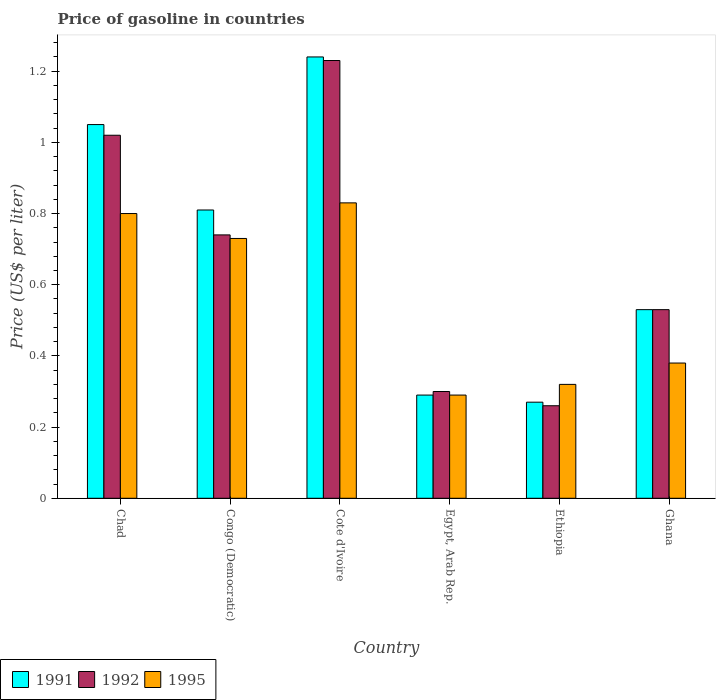Are the number of bars on each tick of the X-axis equal?
Keep it short and to the point. Yes. How many bars are there on the 5th tick from the left?
Ensure brevity in your answer.  3. How many bars are there on the 6th tick from the right?
Your answer should be compact. 3. In how many cases, is the number of bars for a given country not equal to the number of legend labels?
Provide a succinct answer. 0. Across all countries, what is the maximum price of gasoline in 1991?
Make the answer very short. 1.24. Across all countries, what is the minimum price of gasoline in 1991?
Make the answer very short. 0.27. In which country was the price of gasoline in 1992 maximum?
Your answer should be compact. Cote d'Ivoire. In which country was the price of gasoline in 1995 minimum?
Offer a very short reply. Egypt, Arab Rep. What is the total price of gasoline in 1992 in the graph?
Provide a succinct answer. 4.08. What is the difference between the price of gasoline in 1992 in Chad and that in Cote d'Ivoire?
Give a very brief answer. -0.21. What is the difference between the price of gasoline in 1991 in Congo (Democratic) and the price of gasoline in 1992 in Ethiopia?
Provide a short and direct response. 0.55. What is the average price of gasoline in 1991 per country?
Give a very brief answer. 0.7. What is the difference between the price of gasoline of/in 1992 and price of gasoline of/in 1991 in Ethiopia?
Keep it short and to the point. -0.01. What is the ratio of the price of gasoline in 1995 in Chad to that in Congo (Democratic)?
Your response must be concise. 1.1. What is the difference between the highest and the second highest price of gasoline in 1992?
Ensure brevity in your answer.  -0.49. What is the difference between the highest and the lowest price of gasoline in 1995?
Offer a terse response. 0.54. What does the 1st bar from the right in Congo (Democratic) represents?
Ensure brevity in your answer.  1995. Is it the case that in every country, the sum of the price of gasoline in 1991 and price of gasoline in 1995 is greater than the price of gasoline in 1992?
Your answer should be very brief. Yes. How many bars are there?
Make the answer very short. 18. How many countries are there in the graph?
Your answer should be compact. 6. What is the difference between two consecutive major ticks on the Y-axis?
Give a very brief answer. 0.2. Does the graph contain any zero values?
Your answer should be very brief. No. Does the graph contain grids?
Keep it short and to the point. No. Where does the legend appear in the graph?
Provide a succinct answer. Bottom left. What is the title of the graph?
Your answer should be very brief. Price of gasoline in countries. Does "1965" appear as one of the legend labels in the graph?
Your answer should be very brief. No. What is the label or title of the X-axis?
Give a very brief answer. Country. What is the label or title of the Y-axis?
Your answer should be compact. Price (US$ per liter). What is the Price (US$ per liter) of 1995 in Chad?
Offer a very short reply. 0.8. What is the Price (US$ per liter) of 1991 in Congo (Democratic)?
Offer a terse response. 0.81. What is the Price (US$ per liter) of 1992 in Congo (Democratic)?
Your answer should be compact. 0.74. What is the Price (US$ per liter) of 1995 in Congo (Democratic)?
Ensure brevity in your answer.  0.73. What is the Price (US$ per liter) in 1991 in Cote d'Ivoire?
Your answer should be very brief. 1.24. What is the Price (US$ per liter) in 1992 in Cote d'Ivoire?
Your answer should be compact. 1.23. What is the Price (US$ per liter) in 1995 in Cote d'Ivoire?
Offer a very short reply. 0.83. What is the Price (US$ per liter) of 1991 in Egypt, Arab Rep.?
Your answer should be very brief. 0.29. What is the Price (US$ per liter) in 1995 in Egypt, Arab Rep.?
Keep it short and to the point. 0.29. What is the Price (US$ per liter) of 1991 in Ethiopia?
Make the answer very short. 0.27. What is the Price (US$ per liter) of 1992 in Ethiopia?
Your response must be concise. 0.26. What is the Price (US$ per liter) in 1995 in Ethiopia?
Offer a very short reply. 0.32. What is the Price (US$ per liter) in 1991 in Ghana?
Keep it short and to the point. 0.53. What is the Price (US$ per liter) in 1992 in Ghana?
Make the answer very short. 0.53. What is the Price (US$ per liter) of 1995 in Ghana?
Your answer should be very brief. 0.38. Across all countries, what is the maximum Price (US$ per liter) of 1991?
Your response must be concise. 1.24. Across all countries, what is the maximum Price (US$ per liter) in 1992?
Your response must be concise. 1.23. Across all countries, what is the maximum Price (US$ per liter) of 1995?
Offer a very short reply. 0.83. Across all countries, what is the minimum Price (US$ per liter) in 1991?
Your response must be concise. 0.27. Across all countries, what is the minimum Price (US$ per liter) of 1992?
Ensure brevity in your answer.  0.26. Across all countries, what is the minimum Price (US$ per liter) of 1995?
Your answer should be compact. 0.29. What is the total Price (US$ per liter) of 1991 in the graph?
Provide a short and direct response. 4.19. What is the total Price (US$ per liter) of 1992 in the graph?
Your response must be concise. 4.08. What is the total Price (US$ per liter) in 1995 in the graph?
Your answer should be very brief. 3.35. What is the difference between the Price (US$ per liter) in 1991 in Chad and that in Congo (Democratic)?
Provide a succinct answer. 0.24. What is the difference between the Price (US$ per liter) in 1992 in Chad and that in Congo (Democratic)?
Your response must be concise. 0.28. What is the difference between the Price (US$ per liter) of 1995 in Chad and that in Congo (Democratic)?
Provide a succinct answer. 0.07. What is the difference between the Price (US$ per liter) in 1991 in Chad and that in Cote d'Ivoire?
Your response must be concise. -0.19. What is the difference between the Price (US$ per liter) of 1992 in Chad and that in Cote d'Ivoire?
Your answer should be compact. -0.21. What is the difference between the Price (US$ per liter) of 1995 in Chad and that in Cote d'Ivoire?
Offer a very short reply. -0.03. What is the difference between the Price (US$ per liter) in 1991 in Chad and that in Egypt, Arab Rep.?
Provide a succinct answer. 0.76. What is the difference between the Price (US$ per liter) of 1992 in Chad and that in Egypt, Arab Rep.?
Provide a succinct answer. 0.72. What is the difference between the Price (US$ per liter) in 1995 in Chad and that in Egypt, Arab Rep.?
Make the answer very short. 0.51. What is the difference between the Price (US$ per liter) in 1991 in Chad and that in Ethiopia?
Make the answer very short. 0.78. What is the difference between the Price (US$ per liter) of 1992 in Chad and that in Ethiopia?
Offer a very short reply. 0.76. What is the difference between the Price (US$ per liter) of 1995 in Chad and that in Ethiopia?
Offer a terse response. 0.48. What is the difference between the Price (US$ per liter) of 1991 in Chad and that in Ghana?
Provide a short and direct response. 0.52. What is the difference between the Price (US$ per liter) of 1992 in Chad and that in Ghana?
Offer a very short reply. 0.49. What is the difference between the Price (US$ per liter) in 1995 in Chad and that in Ghana?
Your answer should be compact. 0.42. What is the difference between the Price (US$ per liter) of 1991 in Congo (Democratic) and that in Cote d'Ivoire?
Give a very brief answer. -0.43. What is the difference between the Price (US$ per liter) in 1992 in Congo (Democratic) and that in Cote d'Ivoire?
Your response must be concise. -0.49. What is the difference between the Price (US$ per liter) in 1995 in Congo (Democratic) and that in Cote d'Ivoire?
Give a very brief answer. -0.1. What is the difference between the Price (US$ per liter) in 1991 in Congo (Democratic) and that in Egypt, Arab Rep.?
Make the answer very short. 0.52. What is the difference between the Price (US$ per liter) in 1992 in Congo (Democratic) and that in Egypt, Arab Rep.?
Your response must be concise. 0.44. What is the difference between the Price (US$ per liter) of 1995 in Congo (Democratic) and that in Egypt, Arab Rep.?
Make the answer very short. 0.44. What is the difference between the Price (US$ per liter) in 1991 in Congo (Democratic) and that in Ethiopia?
Ensure brevity in your answer.  0.54. What is the difference between the Price (US$ per liter) of 1992 in Congo (Democratic) and that in Ethiopia?
Ensure brevity in your answer.  0.48. What is the difference between the Price (US$ per liter) of 1995 in Congo (Democratic) and that in Ethiopia?
Your answer should be compact. 0.41. What is the difference between the Price (US$ per liter) of 1991 in Congo (Democratic) and that in Ghana?
Make the answer very short. 0.28. What is the difference between the Price (US$ per liter) of 1992 in Congo (Democratic) and that in Ghana?
Provide a short and direct response. 0.21. What is the difference between the Price (US$ per liter) of 1991 in Cote d'Ivoire and that in Egypt, Arab Rep.?
Your answer should be very brief. 0.95. What is the difference between the Price (US$ per liter) in 1992 in Cote d'Ivoire and that in Egypt, Arab Rep.?
Keep it short and to the point. 0.93. What is the difference between the Price (US$ per liter) in 1995 in Cote d'Ivoire and that in Egypt, Arab Rep.?
Keep it short and to the point. 0.54. What is the difference between the Price (US$ per liter) in 1992 in Cote d'Ivoire and that in Ethiopia?
Make the answer very short. 0.97. What is the difference between the Price (US$ per liter) of 1995 in Cote d'Ivoire and that in Ethiopia?
Ensure brevity in your answer.  0.51. What is the difference between the Price (US$ per liter) in 1991 in Cote d'Ivoire and that in Ghana?
Keep it short and to the point. 0.71. What is the difference between the Price (US$ per liter) of 1995 in Cote d'Ivoire and that in Ghana?
Ensure brevity in your answer.  0.45. What is the difference between the Price (US$ per liter) of 1991 in Egypt, Arab Rep. and that in Ethiopia?
Offer a terse response. 0.02. What is the difference between the Price (US$ per liter) in 1992 in Egypt, Arab Rep. and that in Ethiopia?
Offer a very short reply. 0.04. What is the difference between the Price (US$ per liter) in 1995 in Egypt, Arab Rep. and that in Ethiopia?
Ensure brevity in your answer.  -0.03. What is the difference between the Price (US$ per liter) of 1991 in Egypt, Arab Rep. and that in Ghana?
Keep it short and to the point. -0.24. What is the difference between the Price (US$ per liter) in 1992 in Egypt, Arab Rep. and that in Ghana?
Keep it short and to the point. -0.23. What is the difference between the Price (US$ per liter) in 1995 in Egypt, Arab Rep. and that in Ghana?
Your response must be concise. -0.09. What is the difference between the Price (US$ per liter) in 1991 in Ethiopia and that in Ghana?
Your answer should be very brief. -0.26. What is the difference between the Price (US$ per liter) of 1992 in Ethiopia and that in Ghana?
Keep it short and to the point. -0.27. What is the difference between the Price (US$ per liter) in 1995 in Ethiopia and that in Ghana?
Keep it short and to the point. -0.06. What is the difference between the Price (US$ per liter) of 1991 in Chad and the Price (US$ per liter) of 1992 in Congo (Democratic)?
Provide a succinct answer. 0.31. What is the difference between the Price (US$ per liter) of 1991 in Chad and the Price (US$ per liter) of 1995 in Congo (Democratic)?
Your response must be concise. 0.32. What is the difference between the Price (US$ per liter) in 1992 in Chad and the Price (US$ per liter) in 1995 in Congo (Democratic)?
Your response must be concise. 0.29. What is the difference between the Price (US$ per liter) in 1991 in Chad and the Price (US$ per liter) in 1992 in Cote d'Ivoire?
Provide a short and direct response. -0.18. What is the difference between the Price (US$ per liter) of 1991 in Chad and the Price (US$ per liter) of 1995 in Cote d'Ivoire?
Provide a short and direct response. 0.22. What is the difference between the Price (US$ per liter) of 1992 in Chad and the Price (US$ per liter) of 1995 in Cote d'Ivoire?
Your answer should be compact. 0.19. What is the difference between the Price (US$ per liter) in 1991 in Chad and the Price (US$ per liter) in 1992 in Egypt, Arab Rep.?
Keep it short and to the point. 0.75. What is the difference between the Price (US$ per liter) in 1991 in Chad and the Price (US$ per liter) in 1995 in Egypt, Arab Rep.?
Offer a very short reply. 0.76. What is the difference between the Price (US$ per liter) of 1992 in Chad and the Price (US$ per liter) of 1995 in Egypt, Arab Rep.?
Your response must be concise. 0.73. What is the difference between the Price (US$ per liter) of 1991 in Chad and the Price (US$ per liter) of 1992 in Ethiopia?
Provide a succinct answer. 0.79. What is the difference between the Price (US$ per liter) of 1991 in Chad and the Price (US$ per liter) of 1995 in Ethiopia?
Offer a very short reply. 0.73. What is the difference between the Price (US$ per liter) in 1992 in Chad and the Price (US$ per liter) in 1995 in Ethiopia?
Give a very brief answer. 0.7. What is the difference between the Price (US$ per liter) in 1991 in Chad and the Price (US$ per liter) in 1992 in Ghana?
Give a very brief answer. 0.52. What is the difference between the Price (US$ per liter) in 1991 in Chad and the Price (US$ per liter) in 1995 in Ghana?
Your answer should be very brief. 0.67. What is the difference between the Price (US$ per liter) in 1992 in Chad and the Price (US$ per liter) in 1995 in Ghana?
Your answer should be very brief. 0.64. What is the difference between the Price (US$ per liter) of 1991 in Congo (Democratic) and the Price (US$ per liter) of 1992 in Cote d'Ivoire?
Your answer should be compact. -0.42. What is the difference between the Price (US$ per liter) of 1991 in Congo (Democratic) and the Price (US$ per liter) of 1995 in Cote d'Ivoire?
Provide a succinct answer. -0.02. What is the difference between the Price (US$ per liter) of 1992 in Congo (Democratic) and the Price (US$ per liter) of 1995 in Cote d'Ivoire?
Provide a succinct answer. -0.09. What is the difference between the Price (US$ per liter) in 1991 in Congo (Democratic) and the Price (US$ per liter) in 1992 in Egypt, Arab Rep.?
Provide a succinct answer. 0.51. What is the difference between the Price (US$ per liter) of 1991 in Congo (Democratic) and the Price (US$ per liter) of 1995 in Egypt, Arab Rep.?
Keep it short and to the point. 0.52. What is the difference between the Price (US$ per liter) of 1992 in Congo (Democratic) and the Price (US$ per liter) of 1995 in Egypt, Arab Rep.?
Provide a succinct answer. 0.45. What is the difference between the Price (US$ per liter) in 1991 in Congo (Democratic) and the Price (US$ per liter) in 1992 in Ethiopia?
Your answer should be compact. 0.55. What is the difference between the Price (US$ per liter) in 1991 in Congo (Democratic) and the Price (US$ per liter) in 1995 in Ethiopia?
Your answer should be very brief. 0.49. What is the difference between the Price (US$ per liter) in 1992 in Congo (Democratic) and the Price (US$ per liter) in 1995 in Ethiopia?
Your answer should be very brief. 0.42. What is the difference between the Price (US$ per liter) in 1991 in Congo (Democratic) and the Price (US$ per liter) in 1992 in Ghana?
Keep it short and to the point. 0.28. What is the difference between the Price (US$ per liter) in 1991 in Congo (Democratic) and the Price (US$ per liter) in 1995 in Ghana?
Keep it short and to the point. 0.43. What is the difference between the Price (US$ per liter) of 1992 in Congo (Democratic) and the Price (US$ per liter) of 1995 in Ghana?
Provide a short and direct response. 0.36. What is the difference between the Price (US$ per liter) in 1991 in Cote d'Ivoire and the Price (US$ per liter) in 1992 in Egypt, Arab Rep.?
Offer a very short reply. 0.94. What is the difference between the Price (US$ per liter) of 1991 in Cote d'Ivoire and the Price (US$ per liter) of 1995 in Egypt, Arab Rep.?
Keep it short and to the point. 0.95. What is the difference between the Price (US$ per liter) in 1991 in Cote d'Ivoire and the Price (US$ per liter) in 1992 in Ethiopia?
Give a very brief answer. 0.98. What is the difference between the Price (US$ per liter) of 1992 in Cote d'Ivoire and the Price (US$ per liter) of 1995 in Ethiopia?
Provide a short and direct response. 0.91. What is the difference between the Price (US$ per liter) in 1991 in Cote d'Ivoire and the Price (US$ per liter) in 1992 in Ghana?
Offer a very short reply. 0.71. What is the difference between the Price (US$ per liter) in 1991 in Cote d'Ivoire and the Price (US$ per liter) in 1995 in Ghana?
Your answer should be compact. 0.86. What is the difference between the Price (US$ per liter) of 1992 in Cote d'Ivoire and the Price (US$ per liter) of 1995 in Ghana?
Provide a succinct answer. 0.85. What is the difference between the Price (US$ per liter) in 1991 in Egypt, Arab Rep. and the Price (US$ per liter) in 1992 in Ethiopia?
Ensure brevity in your answer.  0.03. What is the difference between the Price (US$ per liter) of 1991 in Egypt, Arab Rep. and the Price (US$ per liter) of 1995 in Ethiopia?
Your answer should be very brief. -0.03. What is the difference between the Price (US$ per liter) in 1992 in Egypt, Arab Rep. and the Price (US$ per liter) in 1995 in Ethiopia?
Offer a terse response. -0.02. What is the difference between the Price (US$ per liter) of 1991 in Egypt, Arab Rep. and the Price (US$ per liter) of 1992 in Ghana?
Make the answer very short. -0.24. What is the difference between the Price (US$ per liter) of 1991 in Egypt, Arab Rep. and the Price (US$ per liter) of 1995 in Ghana?
Your response must be concise. -0.09. What is the difference between the Price (US$ per liter) in 1992 in Egypt, Arab Rep. and the Price (US$ per liter) in 1995 in Ghana?
Make the answer very short. -0.08. What is the difference between the Price (US$ per liter) in 1991 in Ethiopia and the Price (US$ per liter) in 1992 in Ghana?
Provide a succinct answer. -0.26. What is the difference between the Price (US$ per liter) in 1991 in Ethiopia and the Price (US$ per liter) in 1995 in Ghana?
Give a very brief answer. -0.11. What is the difference between the Price (US$ per liter) in 1992 in Ethiopia and the Price (US$ per liter) in 1995 in Ghana?
Ensure brevity in your answer.  -0.12. What is the average Price (US$ per liter) of 1991 per country?
Provide a short and direct response. 0.7. What is the average Price (US$ per liter) of 1992 per country?
Provide a succinct answer. 0.68. What is the average Price (US$ per liter) of 1995 per country?
Your answer should be compact. 0.56. What is the difference between the Price (US$ per liter) in 1991 and Price (US$ per liter) in 1995 in Chad?
Your answer should be very brief. 0.25. What is the difference between the Price (US$ per liter) in 1992 and Price (US$ per liter) in 1995 in Chad?
Your answer should be compact. 0.22. What is the difference between the Price (US$ per liter) in 1991 and Price (US$ per liter) in 1992 in Congo (Democratic)?
Offer a very short reply. 0.07. What is the difference between the Price (US$ per liter) in 1991 and Price (US$ per liter) in 1995 in Congo (Democratic)?
Provide a short and direct response. 0.08. What is the difference between the Price (US$ per liter) in 1991 and Price (US$ per liter) in 1995 in Cote d'Ivoire?
Provide a succinct answer. 0.41. What is the difference between the Price (US$ per liter) in 1991 and Price (US$ per liter) in 1992 in Egypt, Arab Rep.?
Your answer should be very brief. -0.01. What is the difference between the Price (US$ per liter) of 1992 and Price (US$ per liter) of 1995 in Egypt, Arab Rep.?
Your answer should be compact. 0.01. What is the difference between the Price (US$ per liter) in 1991 and Price (US$ per liter) in 1992 in Ethiopia?
Your answer should be very brief. 0.01. What is the difference between the Price (US$ per liter) in 1992 and Price (US$ per liter) in 1995 in Ethiopia?
Provide a succinct answer. -0.06. What is the difference between the Price (US$ per liter) of 1991 and Price (US$ per liter) of 1995 in Ghana?
Your answer should be very brief. 0.15. What is the ratio of the Price (US$ per liter) of 1991 in Chad to that in Congo (Democratic)?
Ensure brevity in your answer.  1.3. What is the ratio of the Price (US$ per liter) of 1992 in Chad to that in Congo (Democratic)?
Make the answer very short. 1.38. What is the ratio of the Price (US$ per liter) of 1995 in Chad to that in Congo (Democratic)?
Your answer should be compact. 1.1. What is the ratio of the Price (US$ per liter) in 1991 in Chad to that in Cote d'Ivoire?
Your response must be concise. 0.85. What is the ratio of the Price (US$ per liter) in 1992 in Chad to that in Cote d'Ivoire?
Give a very brief answer. 0.83. What is the ratio of the Price (US$ per liter) in 1995 in Chad to that in Cote d'Ivoire?
Provide a succinct answer. 0.96. What is the ratio of the Price (US$ per liter) in 1991 in Chad to that in Egypt, Arab Rep.?
Provide a short and direct response. 3.62. What is the ratio of the Price (US$ per liter) in 1992 in Chad to that in Egypt, Arab Rep.?
Offer a very short reply. 3.4. What is the ratio of the Price (US$ per liter) of 1995 in Chad to that in Egypt, Arab Rep.?
Provide a succinct answer. 2.76. What is the ratio of the Price (US$ per liter) of 1991 in Chad to that in Ethiopia?
Ensure brevity in your answer.  3.89. What is the ratio of the Price (US$ per liter) in 1992 in Chad to that in Ethiopia?
Ensure brevity in your answer.  3.92. What is the ratio of the Price (US$ per liter) in 1991 in Chad to that in Ghana?
Your answer should be compact. 1.98. What is the ratio of the Price (US$ per liter) of 1992 in Chad to that in Ghana?
Offer a very short reply. 1.92. What is the ratio of the Price (US$ per liter) of 1995 in Chad to that in Ghana?
Offer a very short reply. 2.11. What is the ratio of the Price (US$ per liter) in 1991 in Congo (Democratic) to that in Cote d'Ivoire?
Keep it short and to the point. 0.65. What is the ratio of the Price (US$ per liter) of 1992 in Congo (Democratic) to that in Cote d'Ivoire?
Provide a succinct answer. 0.6. What is the ratio of the Price (US$ per liter) in 1995 in Congo (Democratic) to that in Cote d'Ivoire?
Give a very brief answer. 0.88. What is the ratio of the Price (US$ per liter) in 1991 in Congo (Democratic) to that in Egypt, Arab Rep.?
Offer a terse response. 2.79. What is the ratio of the Price (US$ per liter) of 1992 in Congo (Democratic) to that in Egypt, Arab Rep.?
Make the answer very short. 2.47. What is the ratio of the Price (US$ per liter) in 1995 in Congo (Democratic) to that in Egypt, Arab Rep.?
Provide a short and direct response. 2.52. What is the ratio of the Price (US$ per liter) in 1991 in Congo (Democratic) to that in Ethiopia?
Provide a succinct answer. 3. What is the ratio of the Price (US$ per liter) of 1992 in Congo (Democratic) to that in Ethiopia?
Your answer should be very brief. 2.85. What is the ratio of the Price (US$ per liter) in 1995 in Congo (Democratic) to that in Ethiopia?
Make the answer very short. 2.28. What is the ratio of the Price (US$ per liter) of 1991 in Congo (Democratic) to that in Ghana?
Your response must be concise. 1.53. What is the ratio of the Price (US$ per liter) in 1992 in Congo (Democratic) to that in Ghana?
Provide a short and direct response. 1.4. What is the ratio of the Price (US$ per liter) in 1995 in Congo (Democratic) to that in Ghana?
Provide a short and direct response. 1.92. What is the ratio of the Price (US$ per liter) in 1991 in Cote d'Ivoire to that in Egypt, Arab Rep.?
Offer a terse response. 4.28. What is the ratio of the Price (US$ per liter) of 1992 in Cote d'Ivoire to that in Egypt, Arab Rep.?
Ensure brevity in your answer.  4.1. What is the ratio of the Price (US$ per liter) of 1995 in Cote d'Ivoire to that in Egypt, Arab Rep.?
Offer a terse response. 2.86. What is the ratio of the Price (US$ per liter) in 1991 in Cote d'Ivoire to that in Ethiopia?
Make the answer very short. 4.59. What is the ratio of the Price (US$ per liter) of 1992 in Cote d'Ivoire to that in Ethiopia?
Provide a short and direct response. 4.73. What is the ratio of the Price (US$ per liter) of 1995 in Cote d'Ivoire to that in Ethiopia?
Make the answer very short. 2.59. What is the ratio of the Price (US$ per liter) in 1991 in Cote d'Ivoire to that in Ghana?
Ensure brevity in your answer.  2.34. What is the ratio of the Price (US$ per liter) of 1992 in Cote d'Ivoire to that in Ghana?
Provide a succinct answer. 2.32. What is the ratio of the Price (US$ per liter) of 1995 in Cote d'Ivoire to that in Ghana?
Make the answer very short. 2.18. What is the ratio of the Price (US$ per liter) in 1991 in Egypt, Arab Rep. to that in Ethiopia?
Ensure brevity in your answer.  1.07. What is the ratio of the Price (US$ per liter) of 1992 in Egypt, Arab Rep. to that in Ethiopia?
Offer a very short reply. 1.15. What is the ratio of the Price (US$ per liter) in 1995 in Egypt, Arab Rep. to that in Ethiopia?
Your response must be concise. 0.91. What is the ratio of the Price (US$ per liter) of 1991 in Egypt, Arab Rep. to that in Ghana?
Your response must be concise. 0.55. What is the ratio of the Price (US$ per liter) in 1992 in Egypt, Arab Rep. to that in Ghana?
Give a very brief answer. 0.57. What is the ratio of the Price (US$ per liter) of 1995 in Egypt, Arab Rep. to that in Ghana?
Offer a very short reply. 0.76. What is the ratio of the Price (US$ per liter) in 1991 in Ethiopia to that in Ghana?
Offer a very short reply. 0.51. What is the ratio of the Price (US$ per liter) of 1992 in Ethiopia to that in Ghana?
Provide a succinct answer. 0.49. What is the ratio of the Price (US$ per liter) of 1995 in Ethiopia to that in Ghana?
Your answer should be very brief. 0.84. What is the difference between the highest and the second highest Price (US$ per liter) of 1991?
Give a very brief answer. 0.19. What is the difference between the highest and the second highest Price (US$ per liter) of 1992?
Provide a succinct answer. 0.21. What is the difference between the highest and the second highest Price (US$ per liter) of 1995?
Your response must be concise. 0.03. What is the difference between the highest and the lowest Price (US$ per liter) of 1991?
Keep it short and to the point. 0.97. What is the difference between the highest and the lowest Price (US$ per liter) of 1995?
Keep it short and to the point. 0.54. 